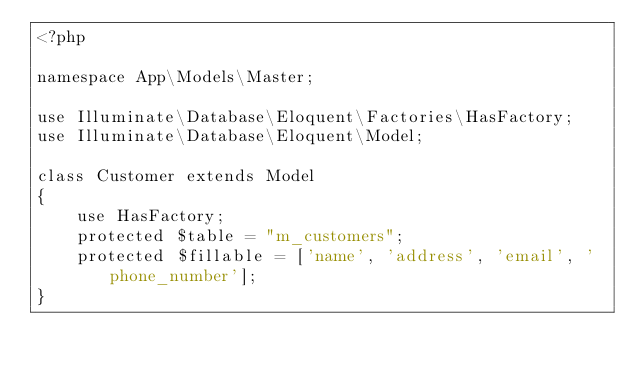Convert code to text. <code><loc_0><loc_0><loc_500><loc_500><_PHP_><?php

namespace App\Models\Master;

use Illuminate\Database\Eloquent\Factories\HasFactory;
use Illuminate\Database\Eloquent\Model;

class Customer extends Model
{
    use HasFactory;
    protected $table = "m_customers";
    protected $fillable = ['name', 'address', 'email', 'phone_number'];
}
</code> 